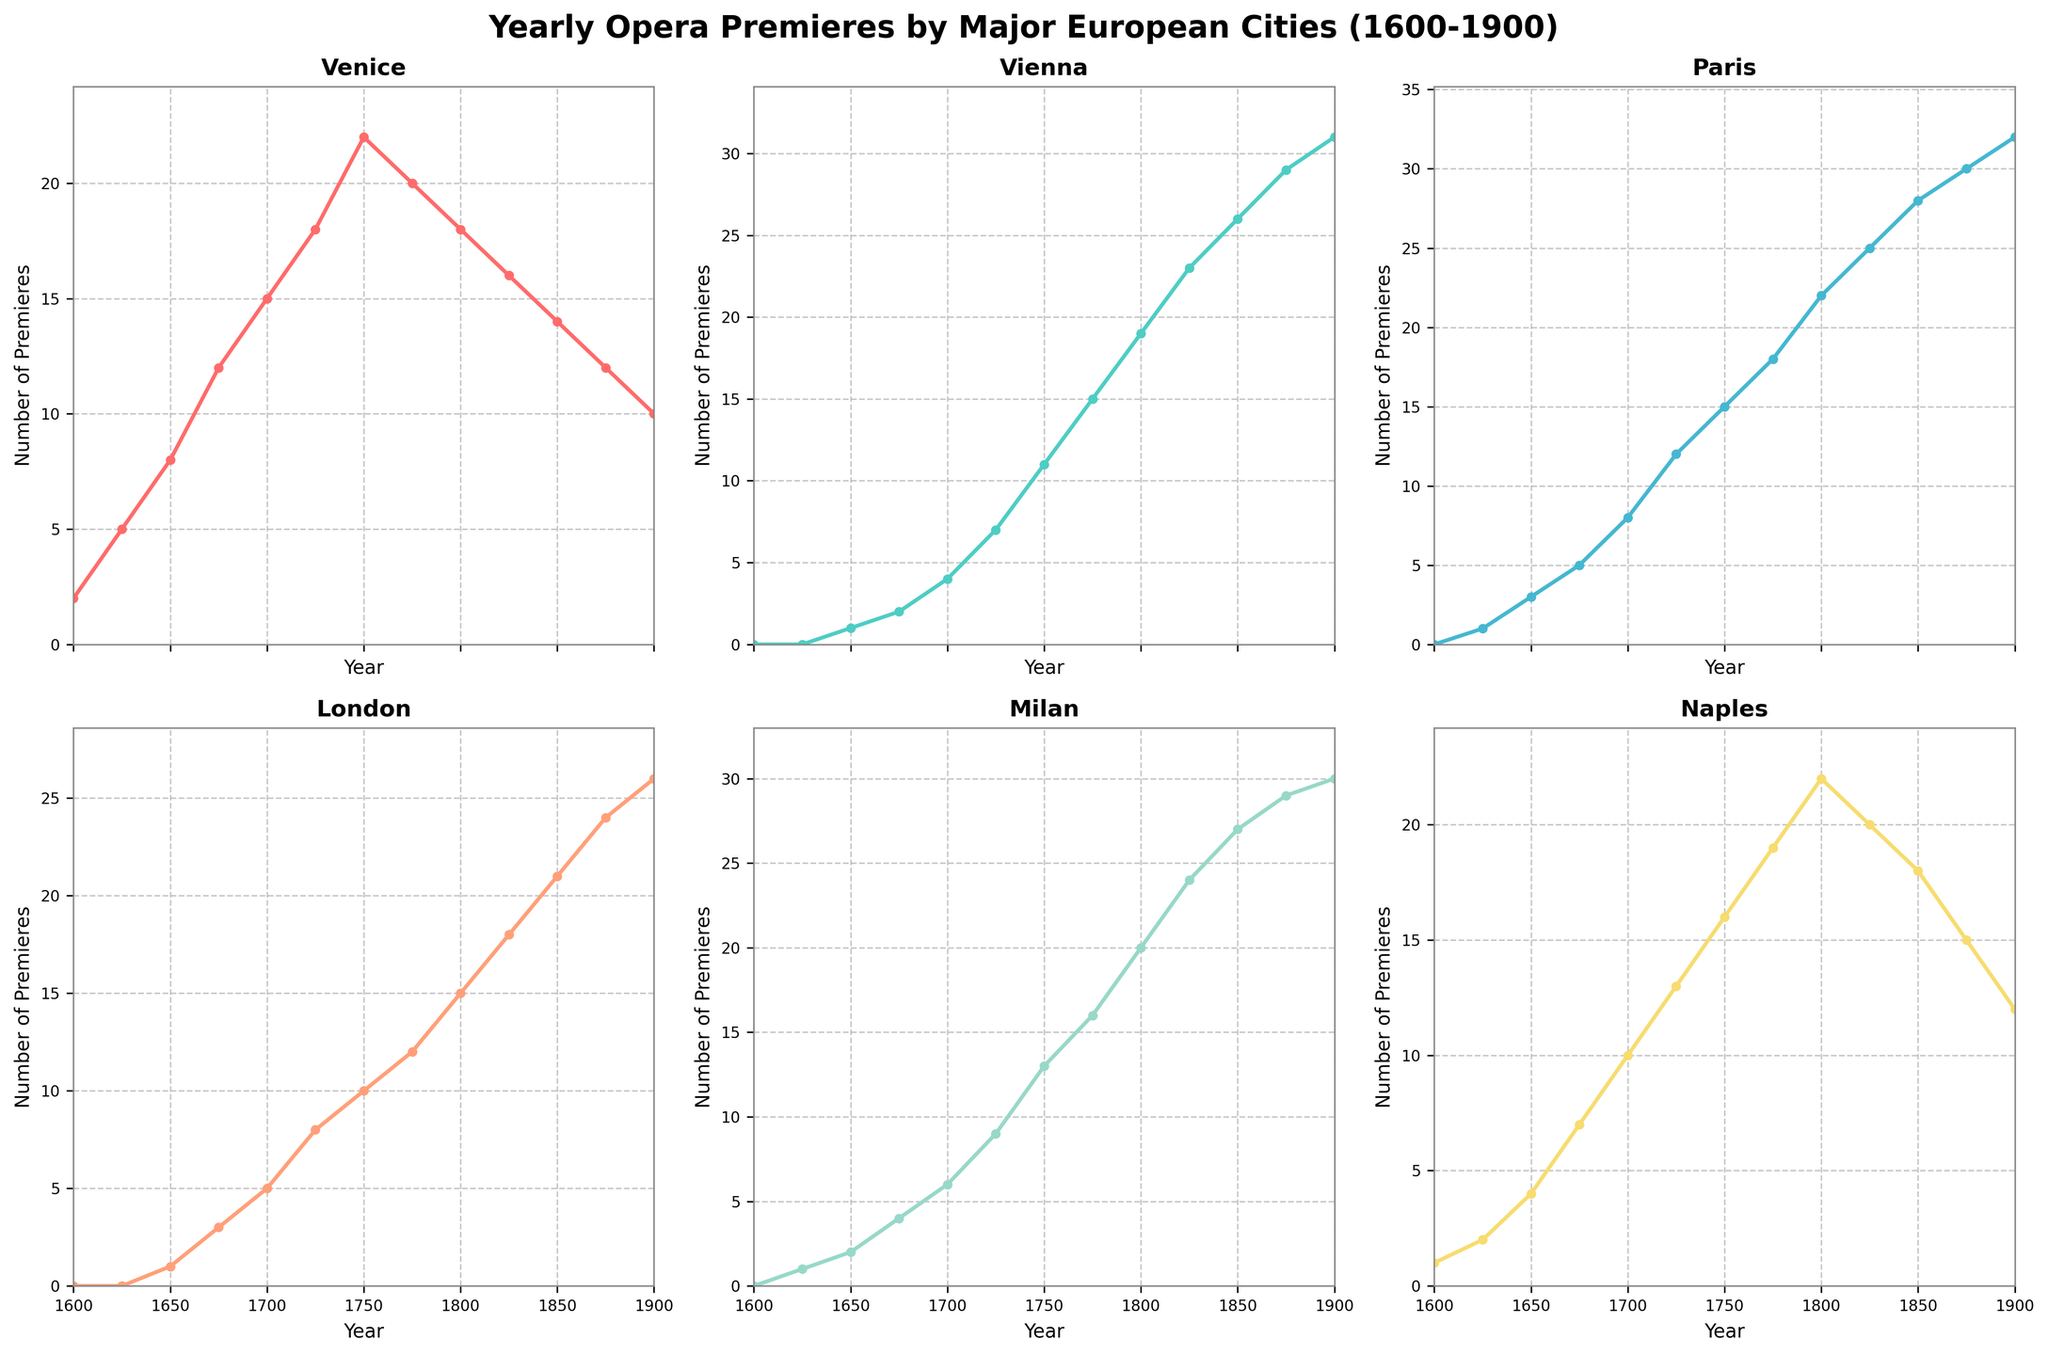How many more opera premieres did Paris have in 1850 compared to London? Look at the figure, find the number of opera premieres in Paris in the year 1850, which is 28, and for London in the same year, which is 21. Subtract the premieres in London from Paris: 28 - 21 = 7
Answer: 7 Which city had the highest number of opera premieres in 1900? Examine each subplot and find the number of opera premieres in the year 1900 for each city. Compare them and identify that Paris had the highest number with 32.
Answer: Paris Between which two years did Vienna see the highest increase in yearly opera premieres? Reviewing the graph for Vienna, examine the differences in the number of premieres between consecutive years. Notice that the largest increase occurred between 1725 (7 premieres) and 1750 (11 premieres), which is an increase of 4 premieres.
Answer: 1725 and 1750 What is the trend in the number of opera premieres in Naples from 1800 to 1900? Observe the line trend of Naples from 1800, which shows 22 premieres, to 1900, which shows 12 premieres. The trend shows a general decrease over the period.
Answer: Decreasing Which city had the lowest number of opera premieres in 1700, and what was the number? Look at each subplot for the year 1700 and find the number of premieres: Venice (15), Vienna (4), Paris (8), London (5), Milan (6), Naples (10). Vienna had the lowest number with 4 premieres.
Answer: Vienna with 4 How did the number of opera premieres in Milan change from 1750 to 1800? In Milan, find the premieres in the years 1750 (13) and 1800 (20). Subtract to find the change: 20 - 13 = 7. Milan saw an increase of 7 premieres.
Answer: Increased by 7 What was the average number of premieres in Venice across the entire timeline shown? Sum the numbers of Venice across all years: 2 + 5 + 8 + 12 + 15 + 18 + 22 + 20 + 18 + 16 + 14 + 12 + 10 = 172. There are 13 data points, so the average is 172 ÷ 13 ≈ 13.23
Answer: 13.23 Between which years did Paris experience the fastest growth in premieres, based on the slope of the lines? Look at the line for Paris and identify the steepest part, which is between 1825 (25 premieres) and 1850 (28 premieres). The number of premieres increased by 3, but considering the slope (difference over time), we need to consider the steepest rise in a smaller time period. This actually occurred between 1700 and 1725 (from 8 to 12, which is a change of 4 within 25 years). However, based on the line's steepness in a general sense, between 1800 and 1825 (22 to 25).
Answer: 1800 to 1825 